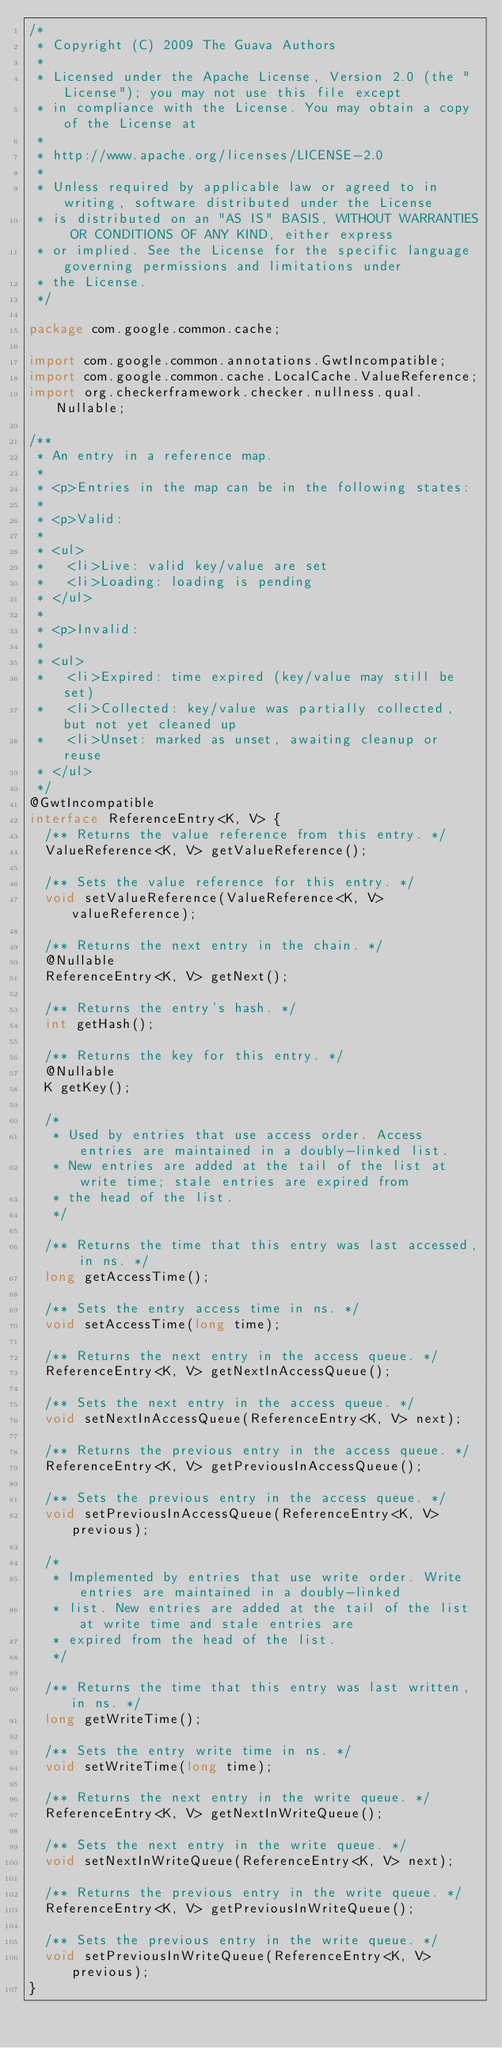<code> <loc_0><loc_0><loc_500><loc_500><_Java_>/*
 * Copyright (C) 2009 The Guava Authors
 *
 * Licensed under the Apache License, Version 2.0 (the "License"); you may not use this file except
 * in compliance with the License. You may obtain a copy of the License at
 *
 * http://www.apache.org/licenses/LICENSE-2.0
 *
 * Unless required by applicable law or agreed to in writing, software distributed under the License
 * is distributed on an "AS IS" BASIS, WITHOUT WARRANTIES OR CONDITIONS OF ANY KIND, either express
 * or implied. See the License for the specific language governing permissions and limitations under
 * the License.
 */

package com.google.common.cache;

import com.google.common.annotations.GwtIncompatible;
import com.google.common.cache.LocalCache.ValueReference;
import org.checkerframework.checker.nullness.qual.Nullable;

/**
 * An entry in a reference map.
 *
 * <p>Entries in the map can be in the following states:
 *
 * <p>Valid:
 *
 * <ul>
 *   <li>Live: valid key/value are set
 *   <li>Loading: loading is pending
 * </ul>
 *
 * <p>Invalid:
 *
 * <ul>
 *   <li>Expired: time expired (key/value may still be set)
 *   <li>Collected: key/value was partially collected, but not yet cleaned up
 *   <li>Unset: marked as unset, awaiting cleanup or reuse
 * </ul>
 */
@GwtIncompatible
interface ReferenceEntry<K, V> {
  /** Returns the value reference from this entry. */
  ValueReference<K, V> getValueReference();

  /** Sets the value reference for this entry. */
  void setValueReference(ValueReference<K, V> valueReference);

  /** Returns the next entry in the chain. */
  @Nullable
  ReferenceEntry<K, V> getNext();

  /** Returns the entry's hash. */
  int getHash();

  /** Returns the key for this entry. */
  @Nullable
  K getKey();

  /*
   * Used by entries that use access order. Access entries are maintained in a doubly-linked list.
   * New entries are added at the tail of the list at write time; stale entries are expired from
   * the head of the list.
   */

  /** Returns the time that this entry was last accessed, in ns. */
  long getAccessTime();

  /** Sets the entry access time in ns. */
  void setAccessTime(long time);

  /** Returns the next entry in the access queue. */
  ReferenceEntry<K, V> getNextInAccessQueue();

  /** Sets the next entry in the access queue. */
  void setNextInAccessQueue(ReferenceEntry<K, V> next);

  /** Returns the previous entry in the access queue. */
  ReferenceEntry<K, V> getPreviousInAccessQueue();

  /** Sets the previous entry in the access queue. */
  void setPreviousInAccessQueue(ReferenceEntry<K, V> previous);

  /*
   * Implemented by entries that use write order. Write entries are maintained in a doubly-linked
   * list. New entries are added at the tail of the list at write time and stale entries are
   * expired from the head of the list.
   */

  /** Returns the time that this entry was last written, in ns. */
  long getWriteTime();

  /** Sets the entry write time in ns. */
  void setWriteTime(long time);

  /** Returns the next entry in the write queue. */
  ReferenceEntry<K, V> getNextInWriteQueue();

  /** Sets the next entry in the write queue. */
  void setNextInWriteQueue(ReferenceEntry<K, V> next);

  /** Returns the previous entry in the write queue. */
  ReferenceEntry<K, V> getPreviousInWriteQueue();

  /** Sets the previous entry in the write queue. */
  void setPreviousInWriteQueue(ReferenceEntry<K, V> previous);
}
</code> 